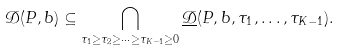<formula> <loc_0><loc_0><loc_500><loc_500>\mathcal { D } ( P , b ) \subseteq \bigcap _ { \tau _ { 1 } \geq \tau _ { 2 } \geq \dots \geq \tau _ { K - 1 } \geq 0 } \underline { \mathcal { D } } ( P , b , \tau _ { 1 } , \dots , \tau _ { K - 1 } ) .</formula> 